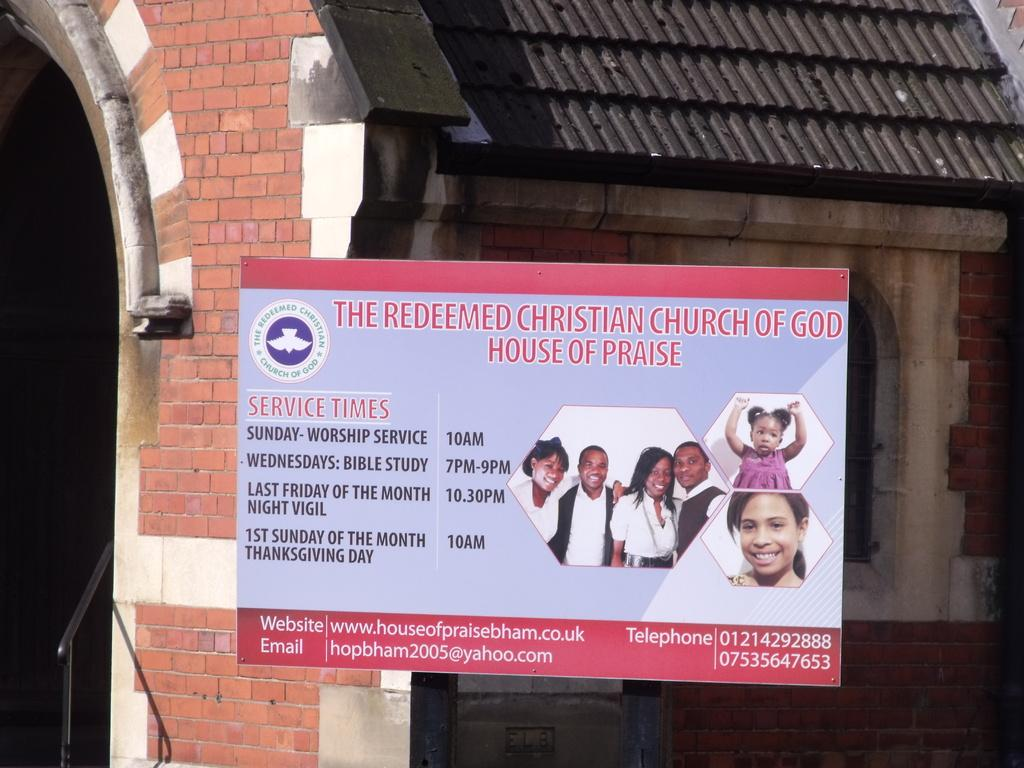What is the main object in the image? There is a display board in the image. What information is displayed on the board? The display board contains church timings. Can you see the church mentioned on the board? Yes, there is a church visible in the image. How many chairs are placed near the display board in the image? There is no mention of chairs in the provided facts, so we cannot determine the number of chairs present in the image. 